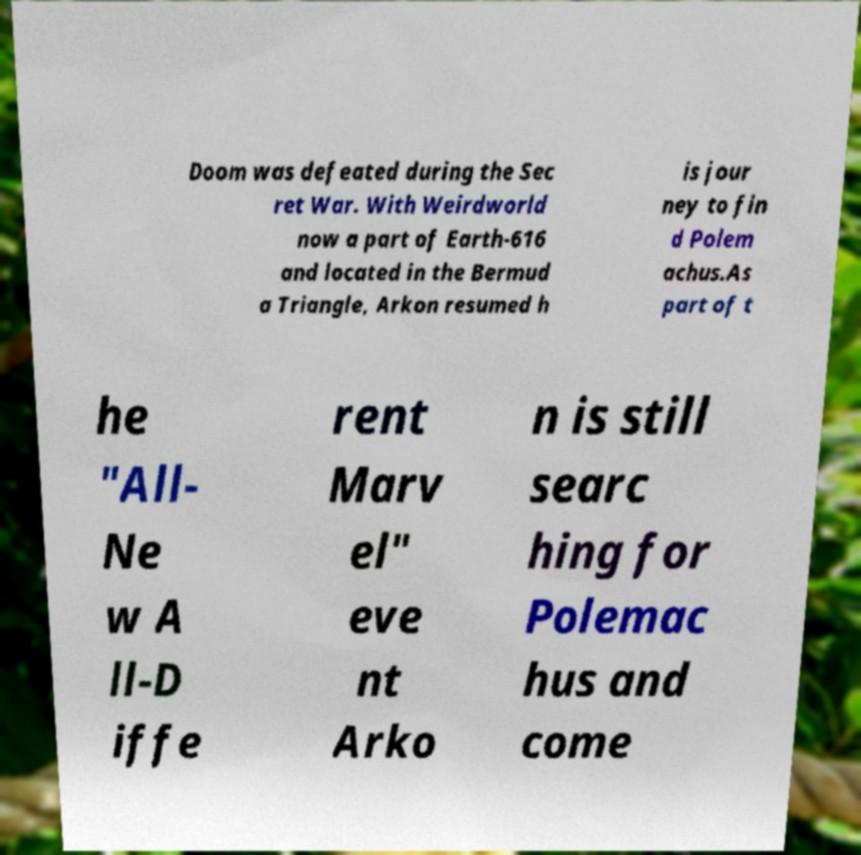I need the written content from this picture converted into text. Can you do that? Doom was defeated during the Sec ret War. With Weirdworld now a part of Earth-616 and located in the Bermud a Triangle, Arkon resumed h is jour ney to fin d Polem achus.As part of t he "All- Ne w A ll-D iffe rent Marv el" eve nt Arko n is still searc hing for Polemac hus and come 